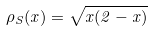Convert formula to latex. <formula><loc_0><loc_0><loc_500><loc_500>\rho _ { S } ( x ) = \sqrt { x ( 2 - x ) }</formula> 